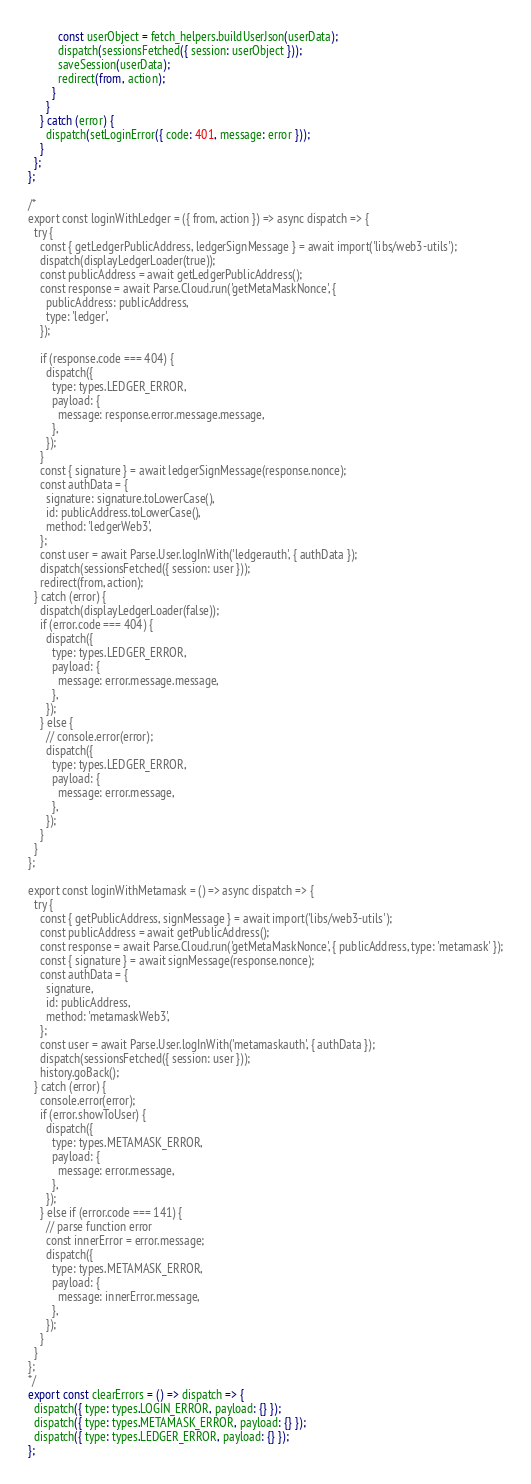Convert code to text. <code><loc_0><loc_0><loc_500><loc_500><_JavaScript_>          const userObject = fetch_helpers.buildUserJson(userData);
          dispatch(sessionsFetched({ session: userObject }));
          saveSession(userData);
          redirect(from, action);
        }
      }
    } catch (error) {
      dispatch(setLoginError({ code: 401, message: error }));
    }
  };
};

/*
export const loginWithLedger = ({ from, action }) => async dispatch => {
  try {
    const { getLedgerPublicAddress, ledgerSignMessage } = await import('libs/web3-utils');
    dispatch(displayLedgerLoader(true));
    const publicAddress = await getLedgerPublicAddress();
    const response = await Parse.Cloud.run('getMetaMaskNonce', {
      publicAddress: publicAddress,
      type: 'ledger',
    });

    if (response.code === 404) {
      dispatch({
        type: types.LEDGER_ERROR,
        payload: {
          message: response.error.message.message,
        },
      });
    }
    const { signature } = await ledgerSignMessage(response.nonce);
    const authData = {
      signature: signature.toLowerCase(),
      id: publicAddress.toLowerCase(),
      method: 'ledgerWeb3',
    };
    const user = await Parse.User.logInWith('ledgerauth', { authData });
    dispatch(sessionsFetched({ session: user }));
    redirect(from, action);
  } catch (error) {
    dispatch(displayLedgerLoader(false));
    if (error.code === 404) {
      dispatch({
        type: types.LEDGER_ERROR,
        payload: {
          message: error.message.message,
        },
      });
    } else {
      // console.error(error);
      dispatch({
        type: types.LEDGER_ERROR,
        payload: {
          message: error.message,
        },
      });
    }
  }
};

export const loginWithMetamask = () => async dispatch => {
  try {
    const { getPublicAddress, signMessage } = await import('libs/web3-utils');
    const publicAddress = await getPublicAddress();
    const response = await Parse.Cloud.run('getMetaMaskNonce', { publicAddress, type: 'metamask' });
    const { signature } = await signMessage(response.nonce);
    const authData = {
      signature,
      id: publicAddress,
      method: 'metamaskWeb3',
    };
    const user = await Parse.User.logInWith('metamaskauth', { authData });
    dispatch(sessionsFetched({ session: user }));
    history.goBack();
  } catch (error) {
    console.error(error);
    if (error.showToUser) {
      dispatch({
        type: types.METAMASK_ERROR,
        payload: {
          message: error.message,
        },
      });
    } else if (error.code === 141) {
      // parse function error
      const innerError = error.message;
      dispatch({
        type: types.METAMASK_ERROR,
        payload: {
          message: innerError.message,
        },
      });
    }
  }
};
*/
export const clearErrors = () => dispatch => {
  dispatch({ type: types.LOGIN_ERROR, payload: {} });
  dispatch({ type: types.METAMASK_ERROR, payload: {} });
  dispatch({ type: types.LEDGER_ERROR, payload: {} });
};
</code> 